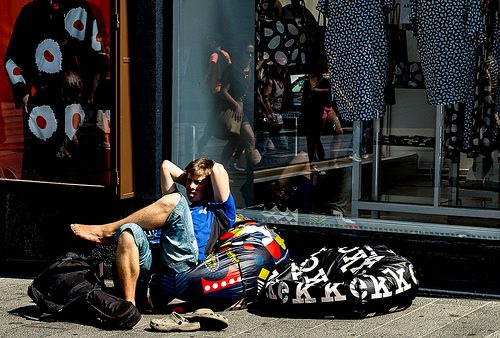<image>
Is the woman in front of the man? Yes. The woman is positioned in front of the man, appearing closer to the camera viewpoint. 